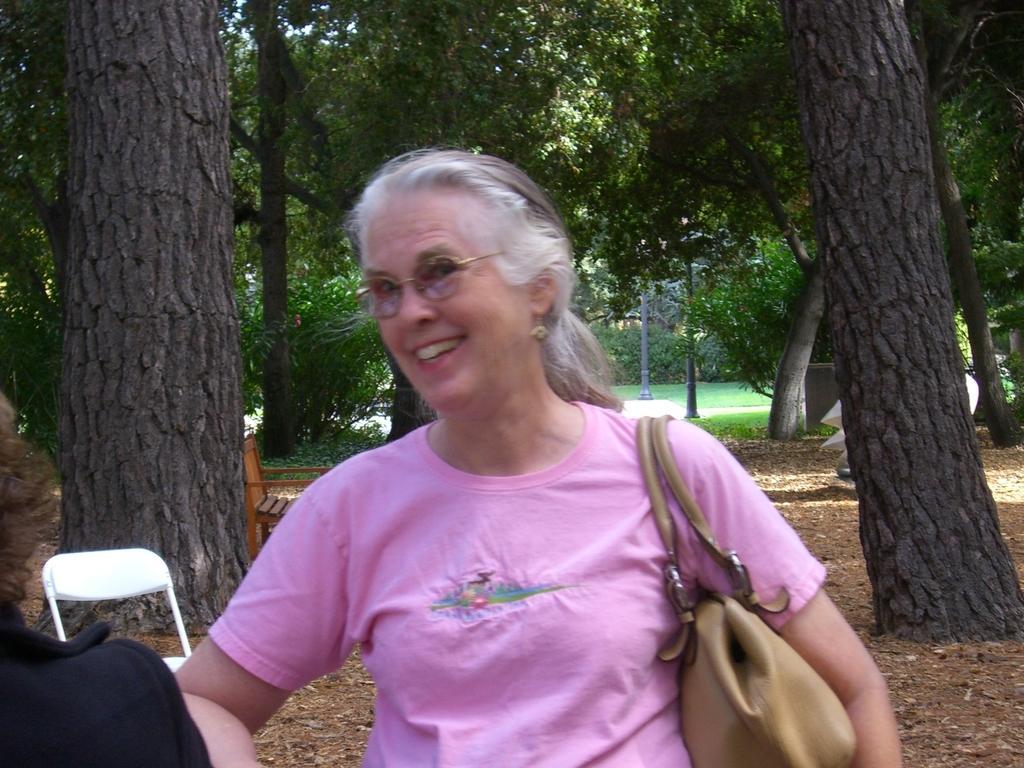Describe this image in one or two sentences. This is an outside view. Here I can see a woman wearing a bag and smiling by looking at the left side. In the bottom left-hand corner there is a person wearing a black color dress. At the back of these people there is a chair. In the background there are many trees and poles and also I can see the grass. It seems to be a garden. On the left side there is a bench. 